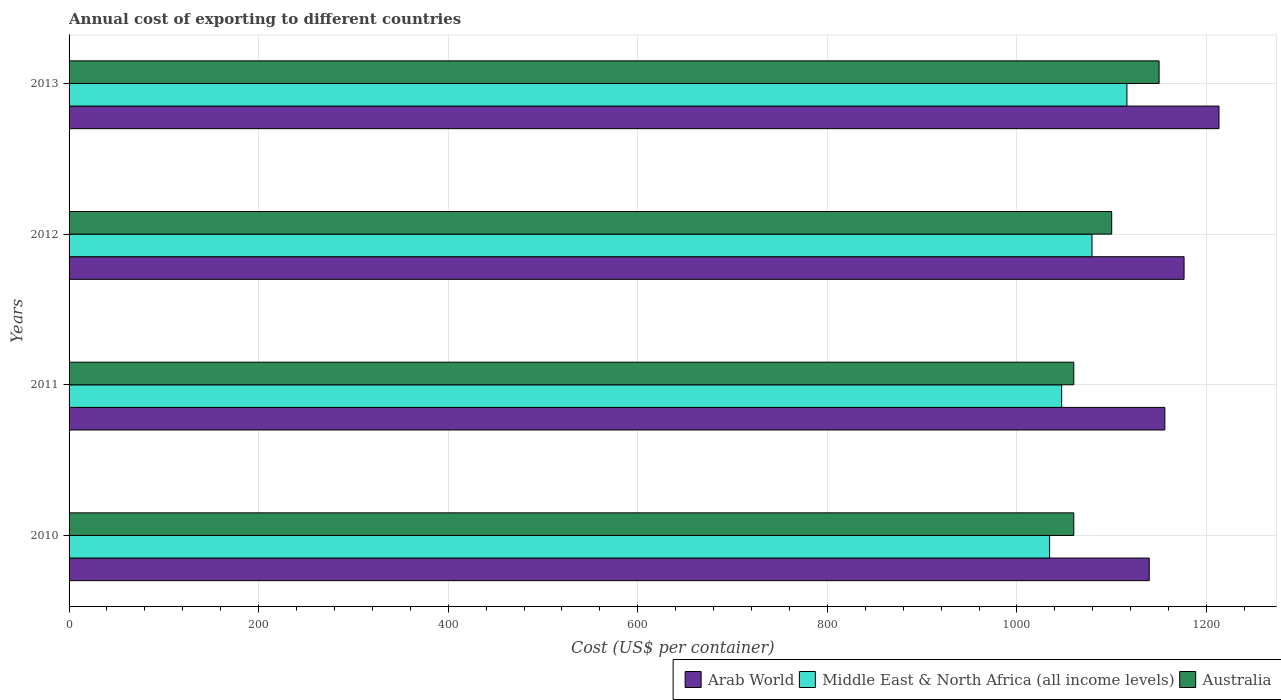How many different coloured bars are there?
Offer a terse response. 3. Are the number of bars per tick equal to the number of legend labels?
Your response must be concise. Yes. Are the number of bars on each tick of the Y-axis equal?
Your response must be concise. Yes. How many bars are there on the 4th tick from the top?
Give a very brief answer. 3. What is the label of the 3rd group of bars from the top?
Provide a succinct answer. 2011. What is the total annual cost of exporting in Australia in 2013?
Offer a very short reply. 1150. Across all years, what is the maximum total annual cost of exporting in Middle East & North Africa (all income levels)?
Give a very brief answer. 1116.05. Across all years, what is the minimum total annual cost of exporting in Australia?
Offer a very short reply. 1060. In which year was the total annual cost of exporting in Middle East & North Africa (all income levels) minimum?
Your answer should be compact. 2010. What is the total total annual cost of exporting in Arab World in the graph?
Your answer should be compact. 4685.17. What is the difference between the total annual cost of exporting in Middle East & North Africa (all income levels) in 2010 and that in 2012?
Provide a short and direct response. -44.72. What is the difference between the total annual cost of exporting in Arab World in 2010 and the total annual cost of exporting in Australia in 2011?
Keep it short and to the point. 79.6. What is the average total annual cost of exporting in Australia per year?
Provide a succinct answer. 1092.5. In the year 2011, what is the difference between the total annual cost of exporting in Arab World and total annual cost of exporting in Australia?
Ensure brevity in your answer.  96.05. In how many years, is the total annual cost of exporting in Arab World greater than 440 US$?
Your response must be concise. 4. What is the ratio of the total annual cost of exporting in Australia in 2011 to that in 2012?
Your answer should be very brief. 0.96. Is the difference between the total annual cost of exporting in Arab World in 2011 and 2013 greater than the difference between the total annual cost of exporting in Australia in 2011 and 2013?
Your answer should be very brief. Yes. What is the difference between the highest and the second highest total annual cost of exporting in Middle East & North Africa (all income levels)?
Make the answer very short. 36.86. What is the difference between the highest and the lowest total annual cost of exporting in Arab World?
Ensure brevity in your answer.  73.59. What does the 2nd bar from the top in 2010 represents?
Offer a very short reply. Middle East & North Africa (all income levels). What does the 1st bar from the bottom in 2011 represents?
Your answer should be compact. Arab World. Are all the bars in the graph horizontal?
Give a very brief answer. Yes. How many years are there in the graph?
Your response must be concise. 4. What is the difference between two consecutive major ticks on the X-axis?
Your response must be concise. 200. Are the values on the major ticks of X-axis written in scientific E-notation?
Offer a very short reply. No. Does the graph contain any zero values?
Provide a succinct answer. No. Where does the legend appear in the graph?
Provide a succinct answer. Bottom right. How many legend labels are there?
Offer a very short reply. 3. What is the title of the graph?
Provide a short and direct response. Annual cost of exporting to different countries. Does "Eritrea" appear as one of the legend labels in the graph?
Offer a terse response. No. What is the label or title of the X-axis?
Your response must be concise. Cost (US$ per container). What is the Cost (US$ per container) in Arab World in 2010?
Provide a succinct answer. 1139.6. What is the Cost (US$ per container) in Middle East & North Africa (all income levels) in 2010?
Your answer should be very brief. 1034.47. What is the Cost (US$ per container) in Australia in 2010?
Offer a very short reply. 1060. What is the Cost (US$ per container) of Arab World in 2011?
Offer a terse response. 1156.05. What is the Cost (US$ per container) in Middle East & North Africa (all income levels) in 2011?
Provide a succinct answer. 1047.2. What is the Cost (US$ per container) of Australia in 2011?
Make the answer very short. 1060. What is the Cost (US$ per container) in Arab World in 2012?
Provide a short and direct response. 1176.33. What is the Cost (US$ per container) of Middle East & North Africa (all income levels) in 2012?
Your response must be concise. 1079.19. What is the Cost (US$ per container) in Australia in 2012?
Offer a very short reply. 1100. What is the Cost (US$ per container) in Arab World in 2013?
Keep it short and to the point. 1213.19. What is the Cost (US$ per container) of Middle East & North Africa (all income levels) in 2013?
Give a very brief answer. 1116.05. What is the Cost (US$ per container) in Australia in 2013?
Provide a short and direct response. 1150. Across all years, what is the maximum Cost (US$ per container) of Arab World?
Offer a terse response. 1213.19. Across all years, what is the maximum Cost (US$ per container) of Middle East & North Africa (all income levels)?
Make the answer very short. 1116.05. Across all years, what is the maximum Cost (US$ per container) in Australia?
Offer a very short reply. 1150. Across all years, what is the minimum Cost (US$ per container) of Arab World?
Your answer should be very brief. 1139.6. Across all years, what is the minimum Cost (US$ per container) in Middle East & North Africa (all income levels)?
Offer a terse response. 1034.47. Across all years, what is the minimum Cost (US$ per container) in Australia?
Keep it short and to the point. 1060. What is the total Cost (US$ per container) of Arab World in the graph?
Your answer should be very brief. 4685.17. What is the total Cost (US$ per container) of Middle East & North Africa (all income levels) in the graph?
Your response must be concise. 4276.91. What is the total Cost (US$ per container) in Australia in the graph?
Provide a succinct answer. 4370. What is the difference between the Cost (US$ per container) of Arab World in 2010 and that in 2011?
Provide a succinct answer. -16.45. What is the difference between the Cost (US$ per container) of Middle East & North Africa (all income levels) in 2010 and that in 2011?
Keep it short and to the point. -12.73. What is the difference between the Cost (US$ per container) in Australia in 2010 and that in 2011?
Give a very brief answer. 0. What is the difference between the Cost (US$ per container) in Arab World in 2010 and that in 2012?
Provide a succinct answer. -36.73. What is the difference between the Cost (US$ per container) in Middle East & North Africa (all income levels) in 2010 and that in 2012?
Ensure brevity in your answer.  -44.72. What is the difference between the Cost (US$ per container) of Arab World in 2010 and that in 2013?
Give a very brief answer. -73.59. What is the difference between the Cost (US$ per container) of Middle East & North Africa (all income levels) in 2010 and that in 2013?
Provide a succinct answer. -81.57. What is the difference between the Cost (US$ per container) in Australia in 2010 and that in 2013?
Make the answer very short. -90. What is the difference between the Cost (US$ per container) of Arab World in 2011 and that in 2012?
Give a very brief answer. -20.28. What is the difference between the Cost (US$ per container) in Middle East & North Africa (all income levels) in 2011 and that in 2012?
Provide a short and direct response. -31.99. What is the difference between the Cost (US$ per container) of Arab World in 2011 and that in 2013?
Make the answer very short. -57.14. What is the difference between the Cost (US$ per container) of Middle East & North Africa (all income levels) in 2011 and that in 2013?
Make the answer very short. -68.85. What is the difference between the Cost (US$ per container) in Australia in 2011 and that in 2013?
Offer a very short reply. -90. What is the difference between the Cost (US$ per container) of Arab World in 2012 and that in 2013?
Provide a succinct answer. -36.86. What is the difference between the Cost (US$ per container) in Middle East & North Africa (all income levels) in 2012 and that in 2013?
Your answer should be very brief. -36.86. What is the difference between the Cost (US$ per container) of Australia in 2012 and that in 2013?
Ensure brevity in your answer.  -50. What is the difference between the Cost (US$ per container) in Arab World in 2010 and the Cost (US$ per container) in Middle East & North Africa (all income levels) in 2011?
Ensure brevity in your answer.  92.4. What is the difference between the Cost (US$ per container) of Arab World in 2010 and the Cost (US$ per container) of Australia in 2011?
Keep it short and to the point. 79.6. What is the difference between the Cost (US$ per container) in Middle East & North Africa (all income levels) in 2010 and the Cost (US$ per container) in Australia in 2011?
Provide a short and direct response. -25.53. What is the difference between the Cost (US$ per container) of Arab World in 2010 and the Cost (US$ per container) of Middle East & North Africa (all income levels) in 2012?
Your answer should be compact. 60.41. What is the difference between the Cost (US$ per container) of Arab World in 2010 and the Cost (US$ per container) of Australia in 2012?
Your answer should be compact. 39.6. What is the difference between the Cost (US$ per container) of Middle East & North Africa (all income levels) in 2010 and the Cost (US$ per container) of Australia in 2012?
Provide a short and direct response. -65.53. What is the difference between the Cost (US$ per container) in Arab World in 2010 and the Cost (US$ per container) in Middle East & North Africa (all income levels) in 2013?
Provide a succinct answer. 23.55. What is the difference between the Cost (US$ per container) in Middle East & North Africa (all income levels) in 2010 and the Cost (US$ per container) in Australia in 2013?
Make the answer very short. -115.53. What is the difference between the Cost (US$ per container) in Arab World in 2011 and the Cost (US$ per container) in Middle East & North Africa (all income levels) in 2012?
Make the answer very short. 76.86. What is the difference between the Cost (US$ per container) of Arab World in 2011 and the Cost (US$ per container) of Australia in 2012?
Give a very brief answer. 56.05. What is the difference between the Cost (US$ per container) in Middle East & North Africa (all income levels) in 2011 and the Cost (US$ per container) in Australia in 2012?
Your response must be concise. -52.8. What is the difference between the Cost (US$ per container) in Arab World in 2011 and the Cost (US$ per container) in Middle East & North Africa (all income levels) in 2013?
Offer a very short reply. 40. What is the difference between the Cost (US$ per container) of Arab World in 2011 and the Cost (US$ per container) of Australia in 2013?
Give a very brief answer. 6.05. What is the difference between the Cost (US$ per container) in Middle East & North Africa (all income levels) in 2011 and the Cost (US$ per container) in Australia in 2013?
Ensure brevity in your answer.  -102.8. What is the difference between the Cost (US$ per container) in Arab World in 2012 and the Cost (US$ per container) in Middle East & North Africa (all income levels) in 2013?
Your response must be concise. 60.29. What is the difference between the Cost (US$ per container) in Arab World in 2012 and the Cost (US$ per container) in Australia in 2013?
Provide a short and direct response. 26.33. What is the difference between the Cost (US$ per container) of Middle East & North Africa (all income levels) in 2012 and the Cost (US$ per container) of Australia in 2013?
Keep it short and to the point. -70.81. What is the average Cost (US$ per container) of Arab World per year?
Keep it short and to the point. 1171.29. What is the average Cost (US$ per container) of Middle East & North Africa (all income levels) per year?
Ensure brevity in your answer.  1069.23. What is the average Cost (US$ per container) in Australia per year?
Provide a succinct answer. 1092.5. In the year 2010, what is the difference between the Cost (US$ per container) of Arab World and Cost (US$ per container) of Middle East & North Africa (all income levels)?
Provide a short and direct response. 105.13. In the year 2010, what is the difference between the Cost (US$ per container) of Arab World and Cost (US$ per container) of Australia?
Your answer should be compact. 79.6. In the year 2010, what is the difference between the Cost (US$ per container) in Middle East & North Africa (all income levels) and Cost (US$ per container) in Australia?
Keep it short and to the point. -25.53. In the year 2011, what is the difference between the Cost (US$ per container) in Arab World and Cost (US$ per container) in Middle East & North Africa (all income levels)?
Your response must be concise. 108.85. In the year 2011, what is the difference between the Cost (US$ per container) in Arab World and Cost (US$ per container) in Australia?
Provide a succinct answer. 96.05. In the year 2011, what is the difference between the Cost (US$ per container) in Middle East & North Africa (all income levels) and Cost (US$ per container) in Australia?
Your response must be concise. -12.8. In the year 2012, what is the difference between the Cost (US$ per container) of Arab World and Cost (US$ per container) of Middle East & North Africa (all income levels)?
Keep it short and to the point. 97.14. In the year 2012, what is the difference between the Cost (US$ per container) in Arab World and Cost (US$ per container) in Australia?
Make the answer very short. 76.33. In the year 2012, what is the difference between the Cost (US$ per container) of Middle East & North Africa (all income levels) and Cost (US$ per container) of Australia?
Make the answer very short. -20.81. In the year 2013, what is the difference between the Cost (US$ per container) of Arab World and Cost (US$ per container) of Middle East & North Africa (all income levels)?
Provide a short and direct response. 97.14. In the year 2013, what is the difference between the Cost (US$ per container) of Arab World and Cost (US$ per container) of Australia?
Provide a short and direct response. 63.19. In the year 2013, what is the difference between the Cost (US$ per container) in Middle East & North Africa (all income levels) and Cost (US$ per container) in Australia?
Your response must be concise. -33.95. What is the ratio of the Cost (US$ per container) of Arab World in 2010 to that in 2011?
Ensure brevity in your answer.  0.99. What is the ratio of the Cost (US$ per container) in Middle East & North Africa (all income levels) in 2010 to that in 2011?
Keep it short and to the point. 0.99. What is the ratio of the Cost (US$ per container) of Australia in 2010 to that in 2011?
Ensure brevity in your answer.  1. What is the ratio of the Cost (US$ per container) in Arab World in 2010 to that in 2012?
Give a very brief answer. 0.97. What is the ratio of the Cost (US$ per container) in Middle East & North Africa (all income levels) in 2010 to that in 2012?
Your answer should be compact. 0.96. What is the ratio of the Cost (US$ per container) of Australia in 2010 to that in 2012?
Give a very brief answer. 0.96. What is the ratio of the Cost (US$ per container) in Arab World in 2010 to that in 2013?
Offer a very short reply. 0.94. What is the ratio of the Cost (US$ per container) of Middle East & North Africa (all income levels) in 2010 to that in 2013?
Give a very brief answer. 0.93. What is the ratio of the Cost (US$ per container) of Australia in 2010 to that in 2013?
Keep it short and to the point. 0.92. What is the ratio of the Cost (US$ per container) in Arab World in 2011 to that in 2012?
Your response must be concise. 0.98. What is the ratio of the Cost (US$ per container) in Middle East & North Africa (all income levels) in 2011 to that in 2012?
Offer a very short reply. 0.97. What is the ratio of the Cost (US$ per container) of Australia in 2011 to that in 2012?
Offer a terse response. 0.96. What is the ratio of the Cost (US$ per container) in Arab World in 2011 to that in 2013?
Give a very brief answer. 0.95. What is the ratio of the Cost (US$ per container) of Middle East & North Africa (all income levels) in 2011 to that in 2013?
Your answer should be compact. 0.94. What is the ratio of the Cost (US$ per container) in Australia in 2011 to that in 2013?
Provide a short and direct response. 0.92. What is the ratio of the Cost (US$ per container) in Arab World in 2012 to that in 2013?
Your response must be concise. 0.97. What is the ratio of the Cost (US$ per container) of Middle East & North Africa (all income levels) in 2012 to that in 2013?
Offer a terse response. 0.97. What is the ratio of the Cost (US$ per container) of Australia in 2012 to that in 2013?
Your response must be concise. 0.96. What is the difference between the highest and the second highest Cost (US$ per container) of Arab World?
Your response must be concise. 36.86. What is the difference between the highest and the second highest Cost (US$ per container) in Middle East & North Africa (all income levels)?
Ensure brevity in your answer.  36.86. What is the difference between the highest and the lowest Cost (US$ per container) of Arab World?
Your answer should be compact. 73.59. What is the difference between the highest and the lowest Cost (US$ per container) in Middle East & North Africa (all income levels)?
Give a very brief answer. 81.57. 